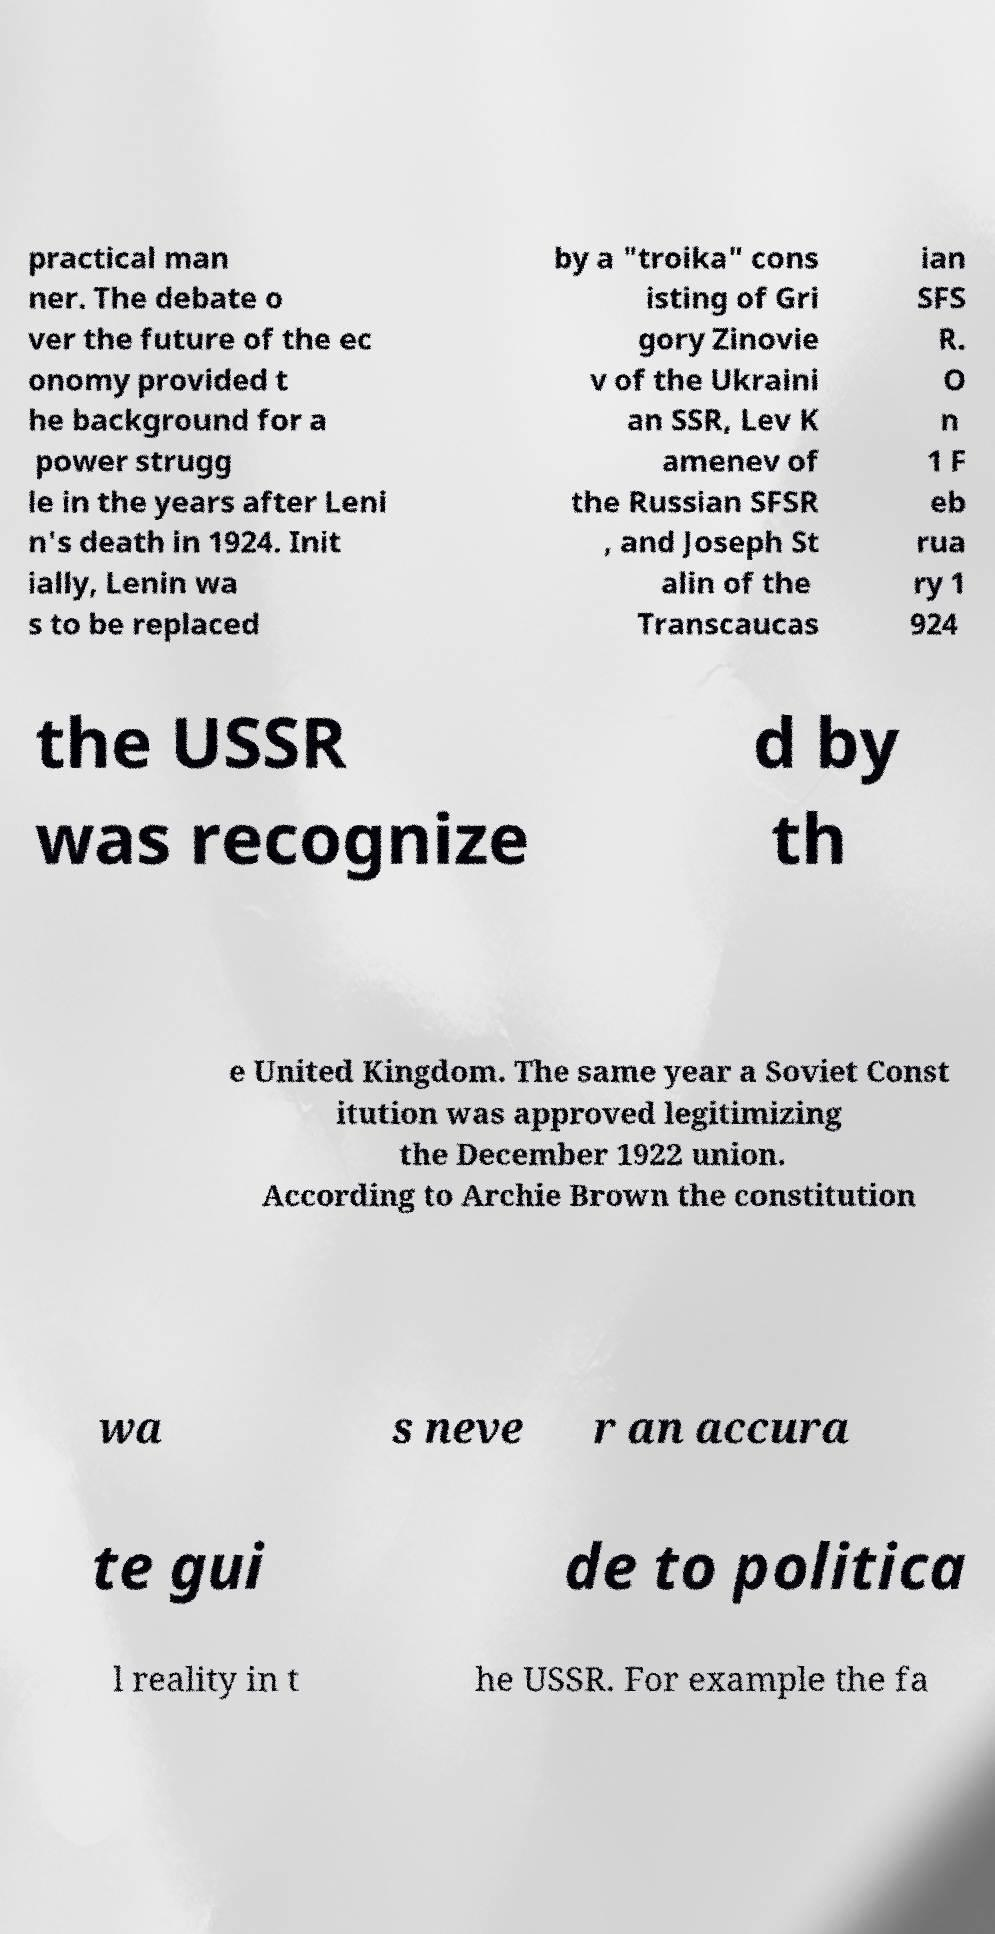Please identify and transcribe the text found in this image. practical man ner. The debate o ver the future of the ec onomy provided t he background for a power strugg le in the years after Leni n's death in 1924. Init ially, Lenin wa s to be replaced by a "troika" cons isting of Gri gory Zinovie v of the Ukraini an SSR, Lev K amenev of the Russian SFSR , and Joseph St alin of the Transcaucas ian SFS R. O n 1 F eb rua ry 1 924 the USSR was recognize d by th e United Kingdom. The same year a Soviet Const itution was approved legitimizing the December 1922 union. According to Archie Brown the constitution wa s neve r an accura te gui de to politica l reality in t he USSR. For example the fa 